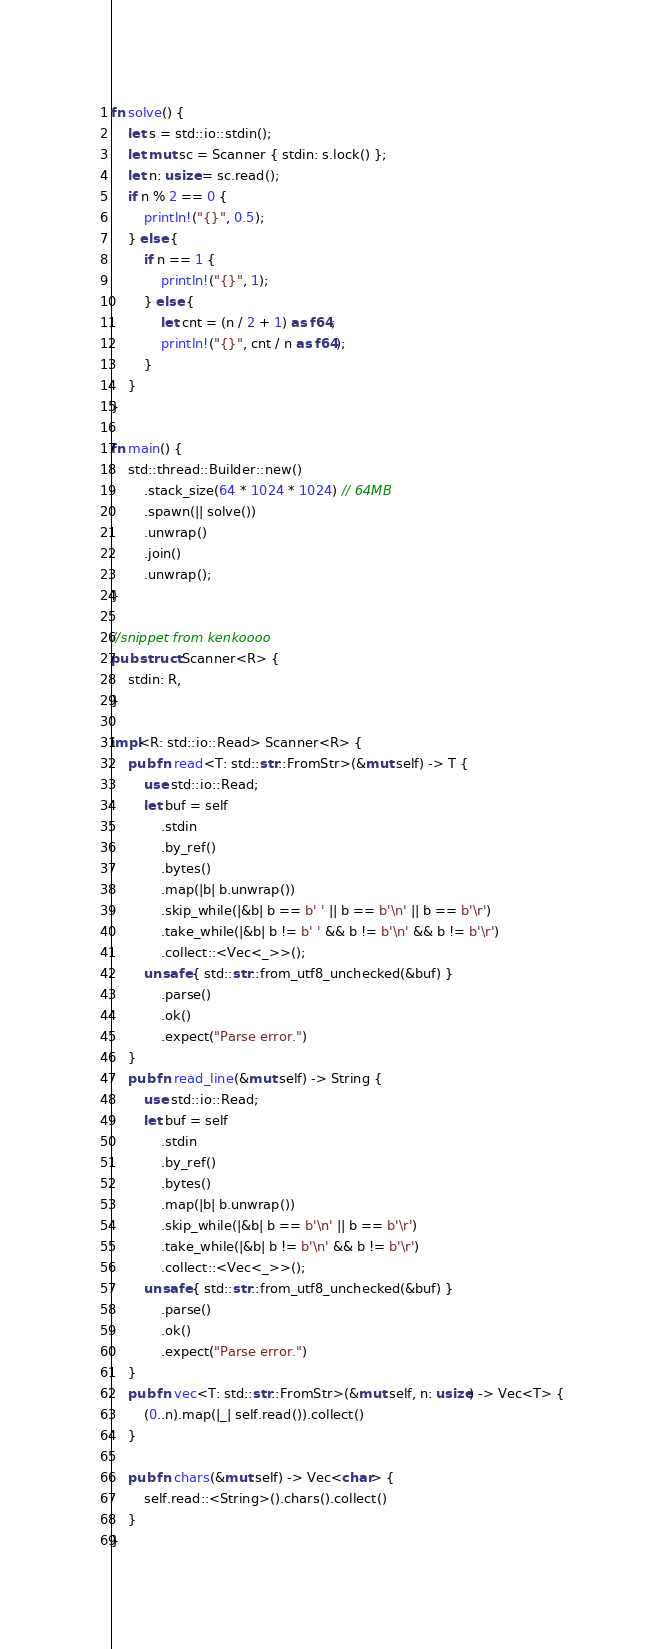<code> <loc_0><loc_0><loc_500><loc_500><_Rust_>fn solve() {
    let s = std::io::stdin();
    let mut sc = Scanner { stdin: s.lock() };
    let n: usize = sc.read();
    if n % 2 == 0 {
        println!("{}", 0.5);
    } else {
        if n == 1 {
            println!("{}", 1);
        } else {
            let cnt = (n / 2 + 1) as f64;
            println!("{}", cnt / n as f64);
        }
    }
}

fn main() {
    std::thread::Builder::new()
        .stack_size(64 * 1024 * 1024) // 64MB
        .spawn(|| solve())
        .unwrap()
        .join()
        .unwrap();
}

//snippet from kenkoooo
pub struct Scanner<R> {
    stdin: R,
}

impl<R: std::io::Read> Scanner<R> {
    pub fn read<T: std::str::FromStr>(&mut self) -> T {
        use std::io::Read;
        let buf = self
            .stdin
            .by_ref()
            .bytes()
            .map(|b| b.unwrap())
            .skip_while(|&b| b == b' ' || b == b'\n' || b == b'\r')
            .take_while(|&b| b != b' ' && b != b'\n' && b != b'\r')
            .collect::<Vec<_>>();
        unsafe { std::str::from_utf8_unchecked(&buf) }
            .parse()
            .ok()
            .expect("Parse error.")
    }
    pub fn read_line(&mut self) -> String {
        use std::io::Read;
        let buf = self
            .stdin
            .by_ref()
            .bytes()
            .map(|b| b.unwrap())
            .skip_while(|&b| b == b'\n' || b == b'\r')
            .take_while(|&b| b != b'\n' && b != b'\r')
            .collect::<Vec<_>>();
        unsafe { std::str::from_utf8_unchecked(&buf) }
            .parse()
            .ok()
            .expect("Parse error.")
    }
    pub fn vec<T: std::str::FromStr>(&mut self, n: usize) -> Vec<T> {
        (0..n).map(|_| self.read()).collect()
    }

    pub fn chars(&mut self) -> Vec<char> {
        self.read::<String>().chars().collect()
    }
}
</code> 